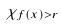<formula> <loc_0><loc_0><loc_500><loc_500>\chi _ { f ( x ) > r }</formula> 